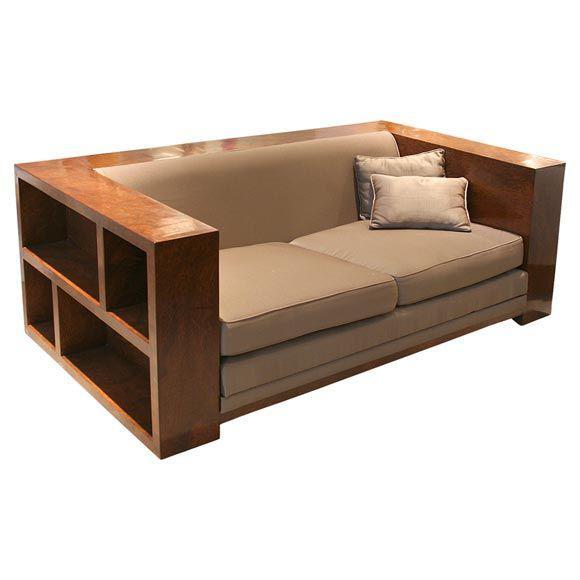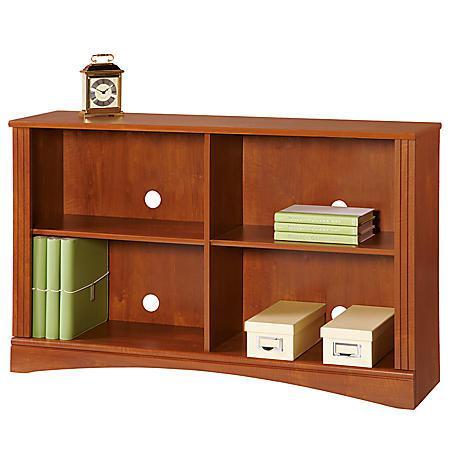The first image is the image on the left, the second image is the image on the right. For the images displayed, is the sentence "there is a bookself with a rug on a wood floor" factually correct? Answer yes or no. No. 